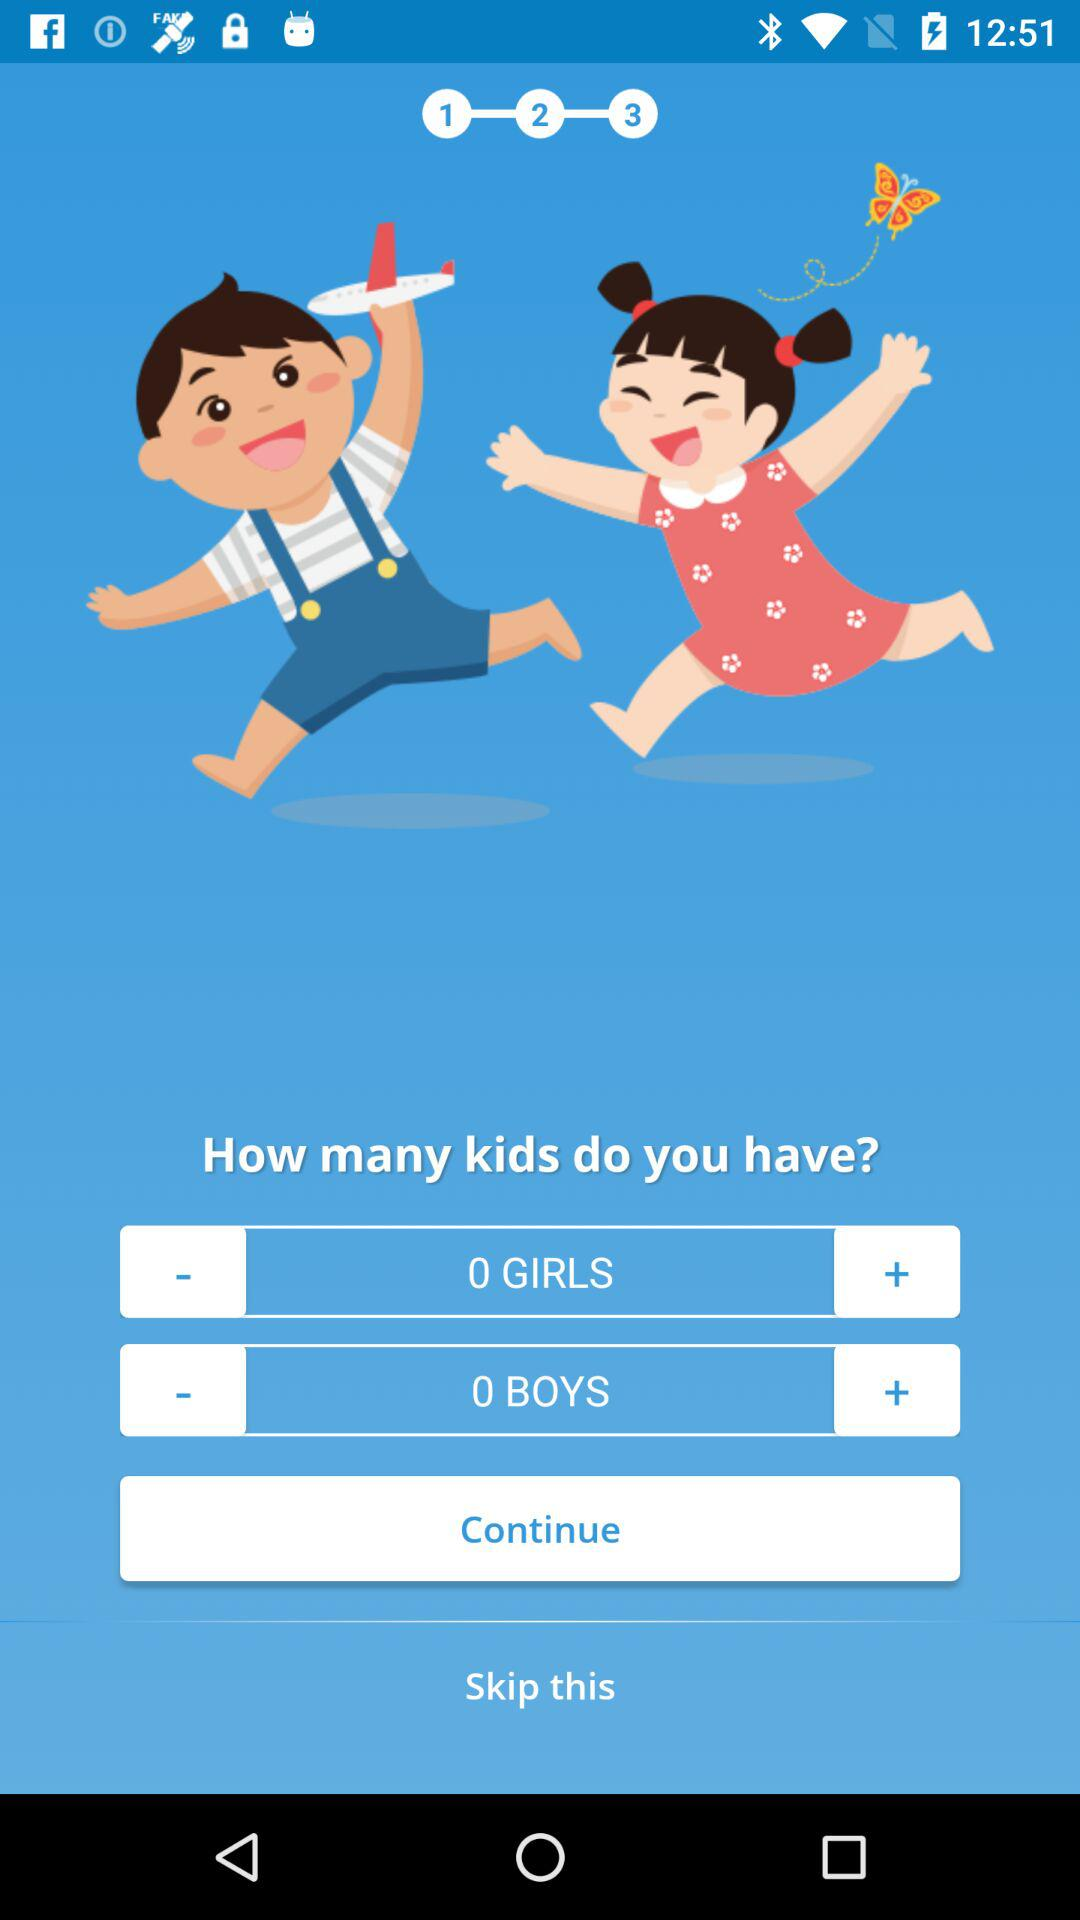How many boys do you have? You have 0 boys. 